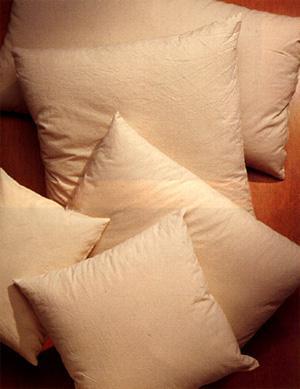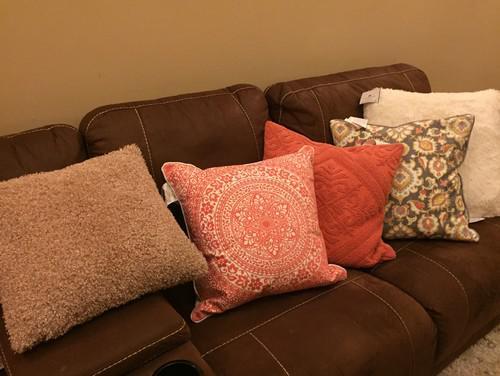The first image is the image on the left, the second image is the image on the right. Given the left and right images, does the statement "A brown sofa holds two pillows decorated with round doily shapes on a dark background." hold true? Answer yes or no. No. The first image is the image on the left, the second image is the image on the right. For the images shown, is this caption "The left image contains at least five pillows." true? Answer yes or no. Yes. 